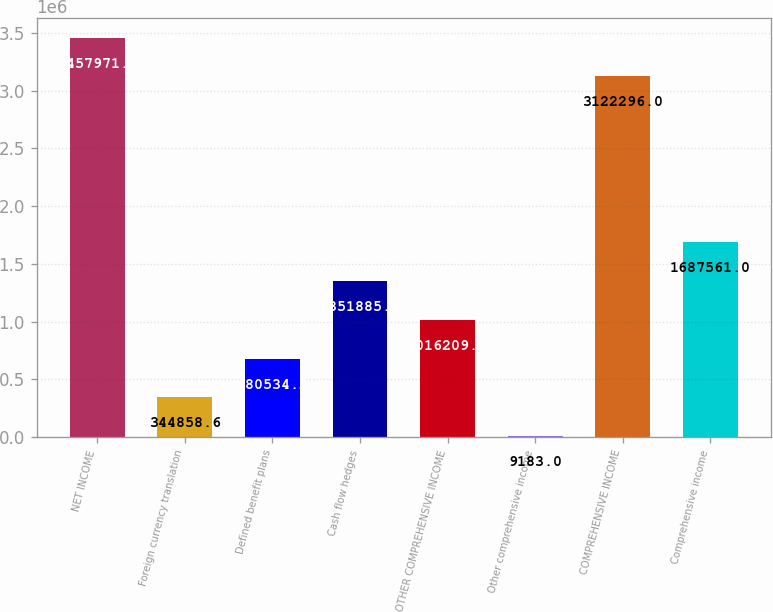<chart> <loc_0><loc_0><loc_500><loc_500><bar_chart><fcel>NET INCOME<fcel>Foreign currency translation<fcel>Defined benefit plans<fcel>Cash flow hedges<fcel>OTHER COMPREHENSIVE INCOME<fcel>Other comprehensive income<fcel>COMPREHENSIVE INCOME<fcel>Comprehensive income<nl><fcel>3.45797e+06<fcel>344859<fcel>680534<fcel>1.35189e+06<fcel>1.01621e+06<fcel>9183<fcel>3.1223e+06<fcel>1.68756e+06<nl></chart> 